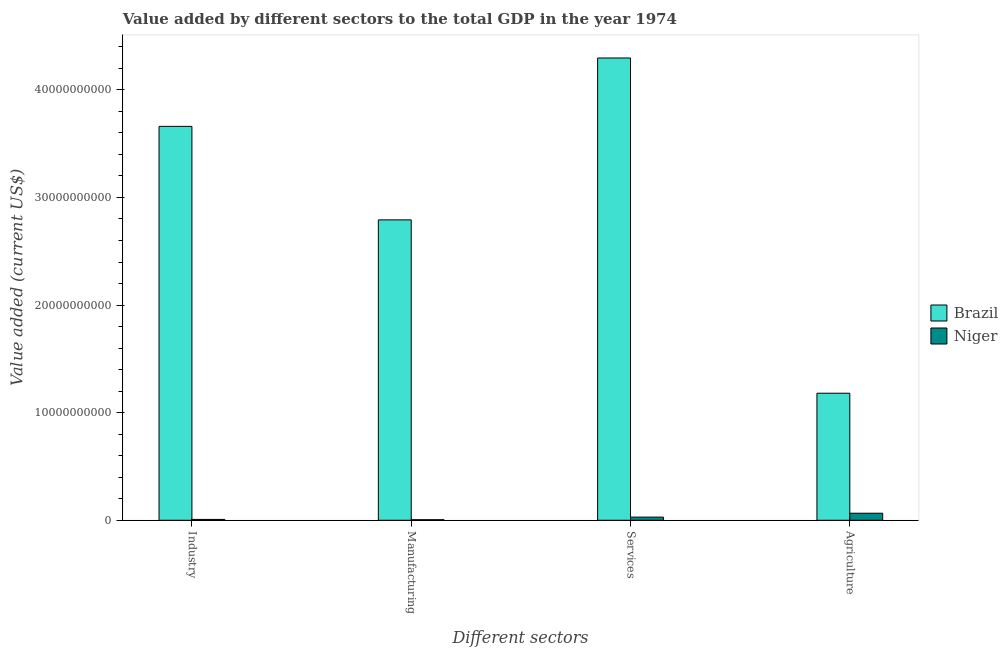How many groups of bars are there?
Your answer should be very brief. 4. Are the number of bars on each tick of the X-axis equal?
Offer a terse response. Yes. What is the label of the 3rd group of bars from the left?
Offer a terse response. Services. What is the value added by manufacturing sector in Niger?
Ensure brevity in your answer.  5.04e+07. Across all countries, what is the maximum value added by services sector?
Ensure brevity in your answer.  4.30e+1. Across all countries, what is the minimum value added by industrial sector?
Your response must be concise. 7.94e+07. In which country was the value added by manufacturing sector maximum?
Provide a succinct answer. Brazil. In which country was the value added by industrial sector minimum?
Keep it short and to the point. Niger. What is the total value added by industrial sector in the graph?
Keep it short and to the point. 3.67e+1. What is the difference between the value added by manufacturing sector in Niger and that in Brazil?
Provide a short and direct response. -2.79e+1. What is the difference between the value added by manufacturing sector in Niger and the value added by industrial sector in Brazil?
Provide a short and direct response. -3.66e+1. What is the average value added by agricultural sector per country?
Your response must be concise. 6.23e+09. What is the difference between the value added by manufacturing sector and value added by services sector in Niger?
Ensure brevity in your answer.  -2.42e+08. In how many countries, is the value added by services sector greater than 16000000000 US$?
Provide a succinct answer. 1. What is the ratio of the value added by manufacturing sector in Niger to that in Brazil?
Your response must be concise. 0. Is the difference between the value added by manufacturing sector in Brazil and Niger greater than the difference between the value added by services sector in Brazil and Niger?
Keep it short and to the point. No. What is the difference between the highest and the second highest value added by industrial sector?
Keep it short and to the point. 3.65e+1. What is the difference between the highest and the lowest value added by industrial sector?
Give a very brief answer. 3.65e+1. In how many countries, is the value added by manufacturing sector greater than the average value added by manufacturing sector taken over all countries?
Your response must be concise. 1. What does the 1st bar from the right in Agriculture represents?
Keep it short and to the point. Niger. How many bars are there?
Ensure brevity in your answer.  8. What is the difference between two consecutive major ticks on the Y-axis?
Your answer should be compact. 1.00e+1. Are the values on the major ticks of Y-axis written in scientific E-notation?
Your answer should be very brief. No. How many legend labels are there?
Provide a succinct answer. 2. What is the title of the graph?
Your response must be concise. Value added by different sectors to the total GDP in the year 1974. Does "Guatemala" appear as one of the legend labels in the graph?
Ensure brevity in your answer.  No. What is the label or title of the X-axis?
Your answer should be compact. Different sectors. What is the label or title of the Y-axis?
Ensure brevity in your answer.  Value added (current US$). What is the Value added (current US$) of Brazil in Industry?
Provide a succinct answer. 3.66e+1. What is the Value added (current US$) in Niger in Industry?
Your response must be concise. 7.94e+07. What is the Value added (current US$) in Brazil in Manufacturing?
Your answer should be very brief. 2.79e+1. What is the Value added (current US$) of Niger in Manufacturing?
Your answer should be compact. 5.04e+07. What is the Value added (current US$) in Brazil in Services?
Offer a very short reply. 4.30e+1. What is the Value added (current US$) of Niger in Services?
Provide a succinct answer. 2.92e+08. What is the Value added (current US$) of Brazil in Agriculture?
Make the answer very short. 1.18e+1. What is the Value added (current US$) of Niger in Agriculture?
Your response must be concise. 6.55e+08. Across all Different sectors, what is the maximum Value added (current US$) in Brazil?
Your response must be concise. 4.30e+1. Across all Different sectors, what is the maximum Value added (current US$) of Niger?
Make the answer very short. 6.55e+08. Across all Different sectors, what is the minimum Value added (current US$) of Brazil?
Offer a very short reply. 1.18e+1. Across all Different sectors, what is the minimum Value added (current US$) in Niger?
Keep it short and to the point. 5.04e+07. What is the total Value added (current US$) of Brazil in the graph?
Ensure brevity in your answer.  1.19e+11. What is the total Value added (current US$) of Niger in the graph?
Ensure brevity in your answer.  1.08e+09. What is the difference between the Value added (current US$) in Brazil in Industry and that in Manufacturing?
Ensure brevity in your answer.  8.69e+09. What is the difference between the Value added (current US$) in Niger in Industry and that in Manufacturing?
Your response must be concise. 2.90e+07. What is the difference between the Value added (current US$) of Brazil in Industry and that in Services?
Keep it short and to the point. -6.35e+09. What is the difference between the Value added (current US$) of Niger in Industry and that in Services?
Provide a short and direct response. -2.13e+08. What is the difference between the Value added (current US$) of Brazil in Industry and that in Agriculture?
Your answer should be very brief. 2.48e+1. What is the difference between the Value added (current US$) in Niger in Industry and that in Agriculture?
Your answer should be compact. -5.75e+08. What is the difference between the Value added (current US$) of Brazil in Manufacturing and that in Services?
Provide a succinct answer. -1.50e+1. What is the difference between the Value added (current US$) of Niger in Manufacturing and that in Services?
Your answer should be compact. -2.42e+08. What is the difference between the Value added (current US$) in Brazil in Manufacturing and that in Agriculture?
Make the answer very short. 1.61e+1. What is the difference between the Value added (current US$) of Niger in Manufacturing and that in Agriculture?
Provide a succinct answer. -6.04e+08. What is the difference between the Value added (current US$) in Brazil in Services and that in Agriculture?
Ensure brevity in your answer.  3.12e+1. What is the difference between the Value added (current US$) in Niger in Services and that in Agriculture?
Ensure brevity in your answer.  -3.62e+08. What is the difference between the Value added (current US$) in Brazil in Industry and the Value added (current US$) in Niger in Manufacturing?
Make the answer very short. 3.66e+1. What is the difference between the Value added (current US$) in Brazil in Industry and the Value added (current US$) in Niger in Services?
Your answer should be compact. 3.63e+1. What is the difference between the Value added (current US$) in Brazil in Industry and the Value added (current US$) in Niger in Agriculture?
Your answer should be compact. 3.60e+1. What is the difference between the Value added (current US$) of Brazil in Manufacturing and the Value added (current US$) of Niger in Services?
Give a very brief answer. 2.76e+1. What is the difference between the Value added (current US$) in Brazil in Manufacturing and the Value added (current US$) in Niger in Agriculture?
Give a very brief answer. 2.73e+1. What is the difference between the Value added (current US$) in Brazil in Services and the Value added (current US$) in Niger in Agriculture?
Your answer should be compact. 4.23e+1. What is the average Value added (current US$) of Brazil per Different sectors?
Keep it short and to the point. 2.98e+1. What is the average Value added (current US$) of Niger per Different sectors?
Offer a terse response. 2.69e+08. What is the difference between the Value added (current US$) in Brazil and Value added (current US$) in Niger in Industry?
Provide a short and direct response. 3.65e+1. What is the difference between the Value added (current US$) in Brazil and Value added (current US$) in Niger in Manufacturing?
Your response must be concise. 2.79e+1. What is the difference between the Value added (current US$) in Brazil and Value added (current US$) in Niger in Services?
Offer a terse response. 4.27e+1. What is the difference between the Value added (current US$) in Brazil and Value added (current US$) in Niger in Agriculture?
Offer a terse response. 1.12e+1. What is the ratio of the Value added (current US$) of Brazil in Industry to that in Manufacturing?
Keep it short and to the point. 1.31. What is the ratio of the Value added (current US$) in Niger in Industry to that in Manufacturing?
Offer a very short reply. 1.58. What is the ratio of the Value added (current US$) of Brazil in Industry to that in Services?
Offer a very short reply. 0.85. What is the ratio of the Value added (current US$) in Niger in Industry to that in Services?
Your answer should be compact. 0.27. What is the ratio of the Value added (current US$) of Brazil in Industry to that in Agriculture?
Make the answer very short. 3.1. What is the ratio of the Value added (current US$) in Niger in Industry to that in Agriculture?
Keep it short and to the point. 0.12. What is the ratio of the Value added (current US$) in Brazil in Manufacturing to that in Services?
Keep it short and to the point. 0.65. What is the ratio of the Value added (current US$) of Niger in Manufacturing to that in Services?
Offer a very short reply. 0.17. What is the ratio of the Value added (current US$) in Brazil in Manufacturing to that in Agriculture?
Make the answer very short. 2.36. What is the ratio of the Value added (current US$) of Niger in Manufacturing to that in Agriculture?
Provide a short and direct response. 0.08. What is the ratio of the Value added (current US$) of Brazil in Services to that in Agriculture?
Provide a succinct answer. 3.64. What is the ratio of the Value added (current US$) in Niger in Services to that in Agriculture?
Offer a very short reply. 0.45. What is the difference between the highest and the second highest Value added (current US$) in Brazil?
Your response must be concise. 6.35e+09. What is the difference between the highest and the second highest Value added (current US$) in Niger?
Keep it short and to the point. 3.62e+08. What is the difference between the highest and the lowest Value added (current US$) of Brazil?
Your response must be concise. 3.12e+1. What is the difference between the highest and the lowest Value added (current US$) in Niger?
Your response must be concise. 6.04e+08. 